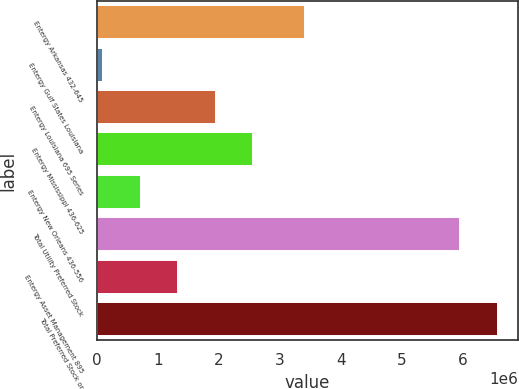Convert chart. <chart><loc_0><loc_0><loc_500><loc_500><bar_chart><fcel>Entergy Arkansas 432-645<fcel>Entergy Gulf States Louisiana<fcel>Entergy Louisiana 695 Series<fcel>Entergy Mississippi 436-625<fcel>Entergy New Orleans 436-556<fcel>Total Utility Preferred Stock<fcel>Entergy Asset Management 895<fcel>Total Preferred Stock or<nl><fcel>3.4135e+06<fcel>100000<fcel>1.94574e+06<fcel>2.56099e+06<fcel>715248<fcel>5.9551e+06<fcel>1.3305e+06<fcel>6.57035e+06<nl></chart> 